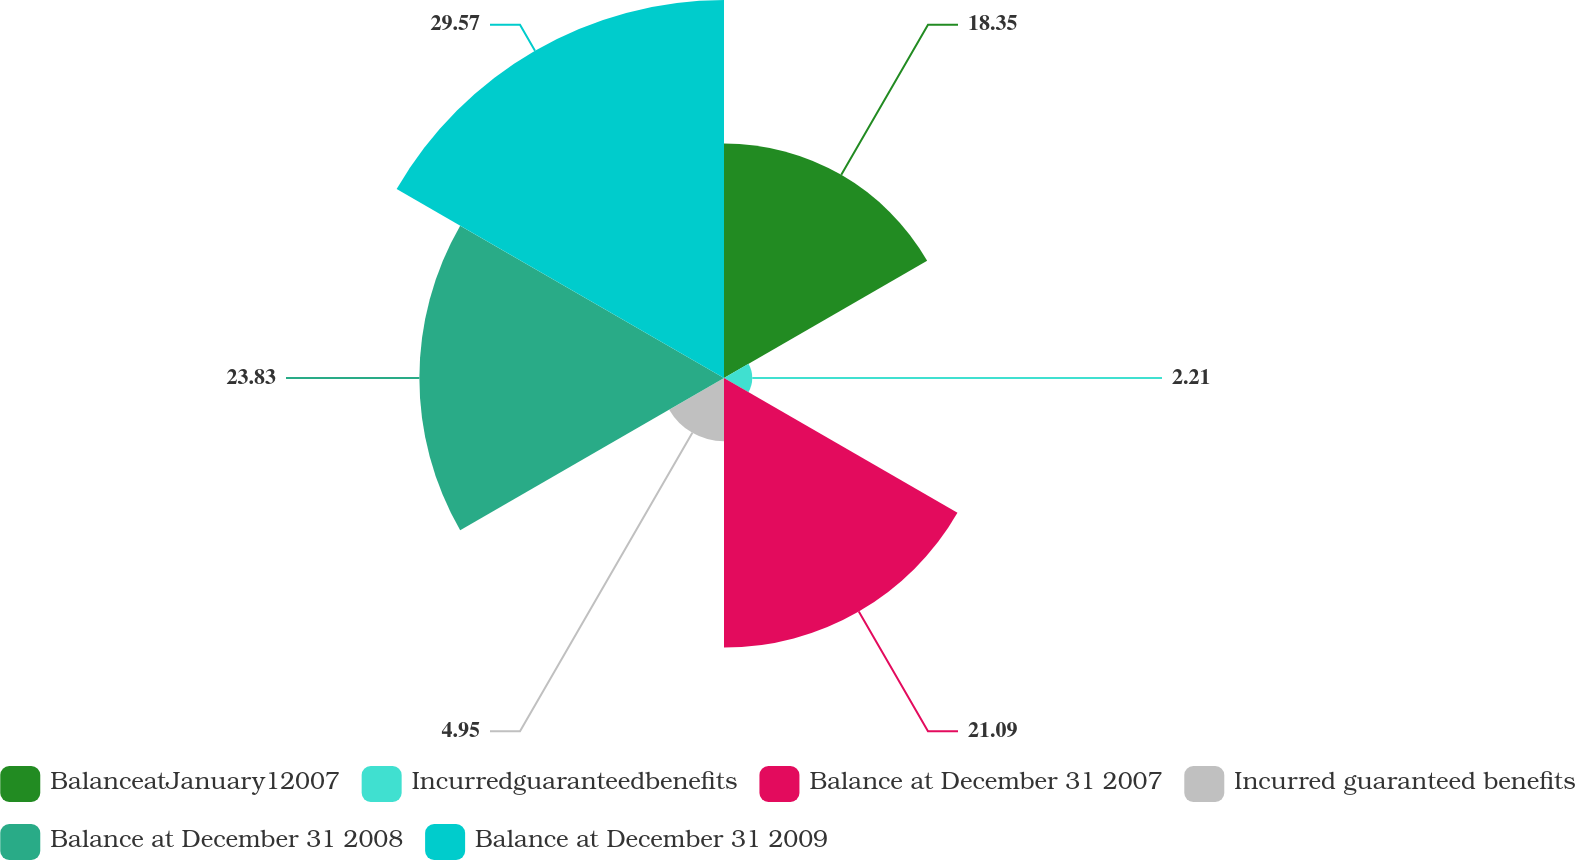Convert chart to OTSL. <chart><loc_0><loc_0><loc_500><loc_500><pie_chart><fcel>BalanceatJanuary12007<fcel>Incurredguaranteedbenefits<fcel>Balance at December 31 2007<fcel>Incurred guaranteed benefits<fcel>Balance at December 31 2008<fcel>Balance at December 31 2009<nl><fcel>18.35%<fcel>2.21%<fcel>21.09%<fcel>4.95%<fcel>23.83%<fcel>29.57%<nl></chart> 